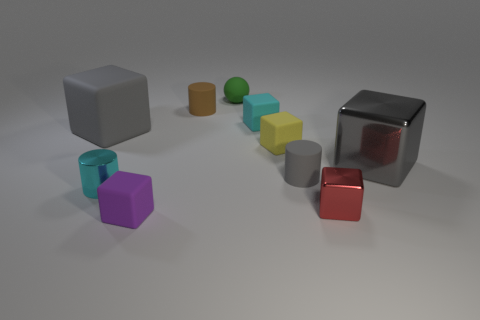Subtract all big metallic cubes. How many cubes are left? 5 Subtract all brown cylinders. How many cylinders are left? 2 Subtract all spheres. How many objects are left? 9 Subtract all purple blocks. Subtract all cyan spheres. How many blocks are left? 5 Subtract all red spheres. How many blue cubes are left? 0 Subtract all cyan shiny cylinders. Subtract all small green things. How many objects are left? 8 Add 5 small blocks. How many small blocks are left? 9 Add 2 gray cubes. How many gray cubes exist? 4 Subtract 0 red cylinders. How many objects are left? 10 Subtract 1 spheres. How many spheres are left? 0 